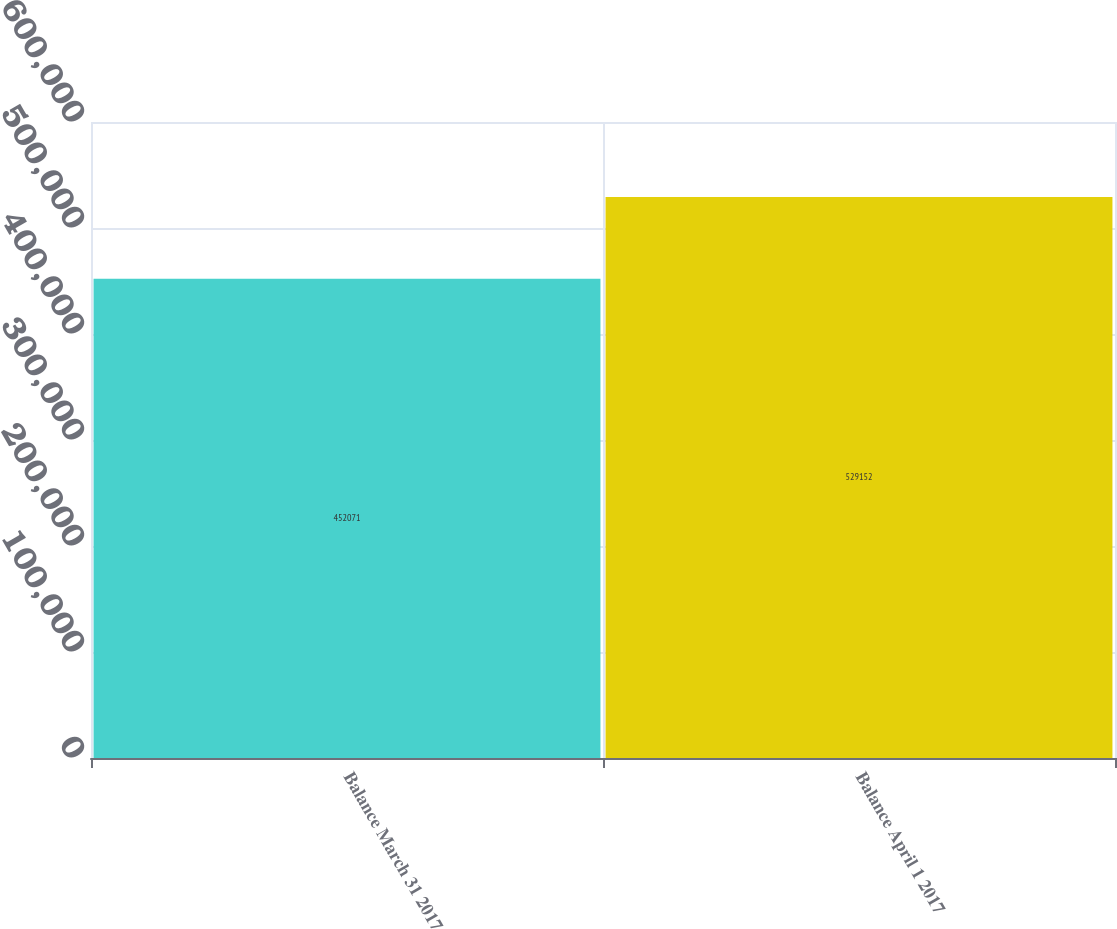Convert chart to OTSL. <chart><loc_0><loc_0><loc_500><loc_500><bar_chart><fcel>Balance March 31 2017<fcel>Balance April 1 2017<nl><fcel>452071<fcel>529152<nl></chart> 